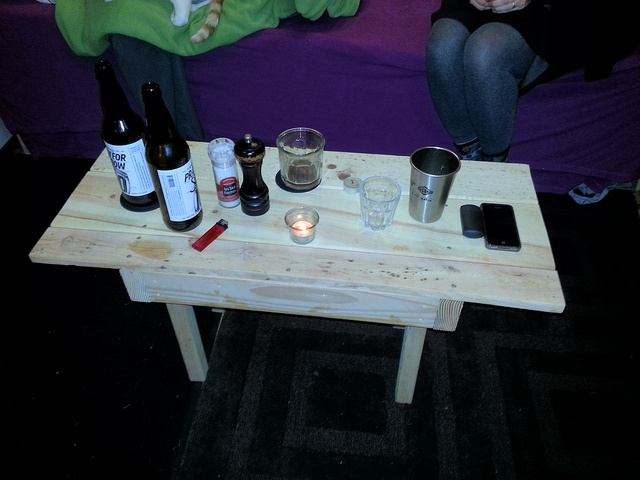Describe the objects in this image and their specific colors. I can see bed in black, navy, teal, and purple tones, dining table in black, darkgray, lightblue, and gray tones, couch in black, navy, purple, and gray tones, people in black, navy, darkblue, and gray tones, and people in black, darkgreen, and green tones in this image. 